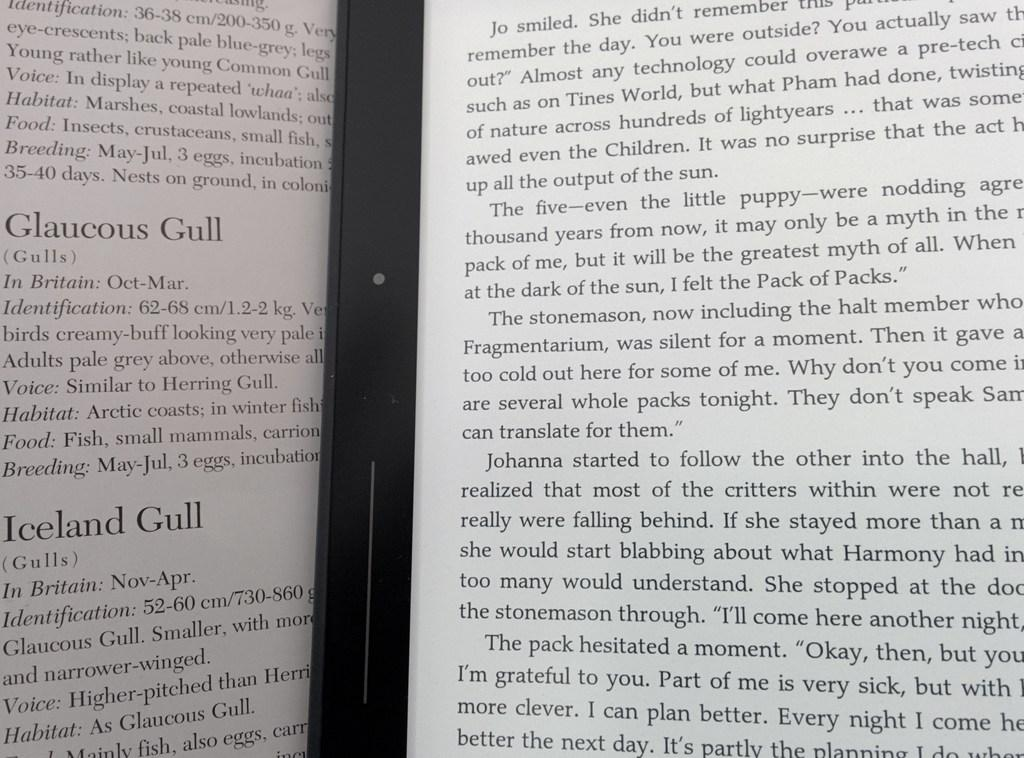<image>
Write a terse but informative summary of the picture. A book is opened to a section titled Iceland Gull. 